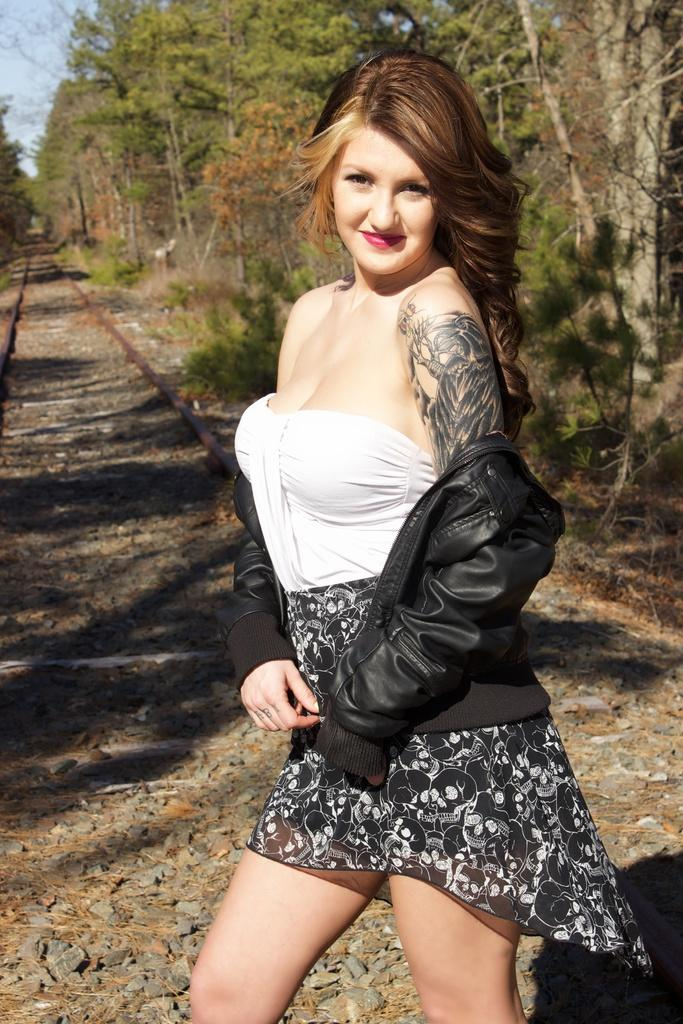Who is the main subject in the image? There is a lady in the image. What is the lady doing in the image? The lady is standing on a track and posing for a photograph. What can be seen in the background of the image? There are trees in the background of the image. What type of cave can be seen in the background of the image? There is no cave present in the image; it features a lady standing on a track and trees in the background. 